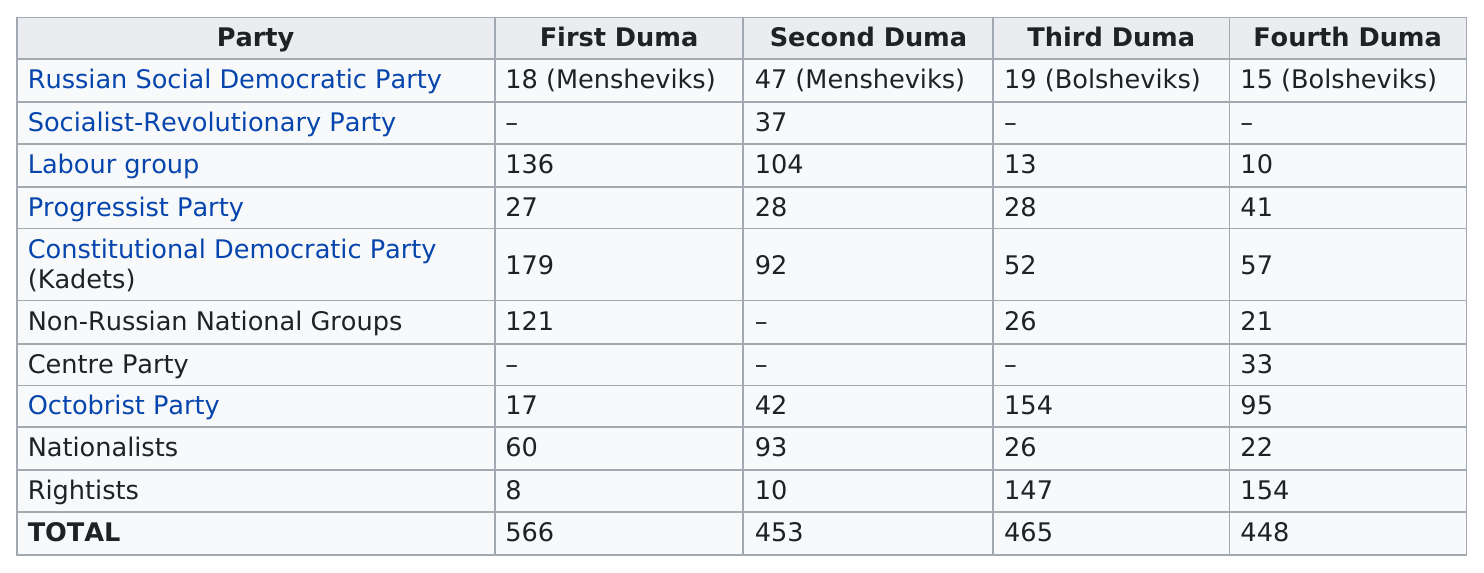Indicate a few pertinent items in this graphic. The next largest party to hold seats in the first Duma after the Kadets was the Labour Group. In the fourth Duma, a total of 448 seats were taken. In the Second Duma, the Labour Group had the largest number of representatives. The total number of seats in the fourth Duma was 448. For how long was the first Duma session on the rightists? 8.. 